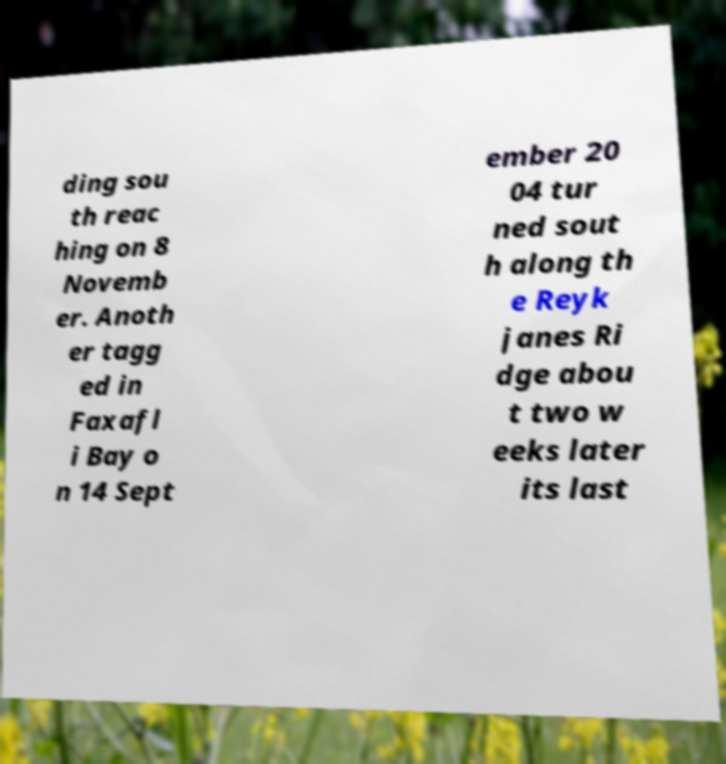There's text embedded in this image that I need extracted. Can you transcribe it verbatim? ding sou th reac hing on 8 Novemb er. Anoth er tagg ed in Faxafl i Bay o n 14 Sept ember 20 04 tur ned sout h along th e Reyk janes Ri dge abou t two w eeks later its last 